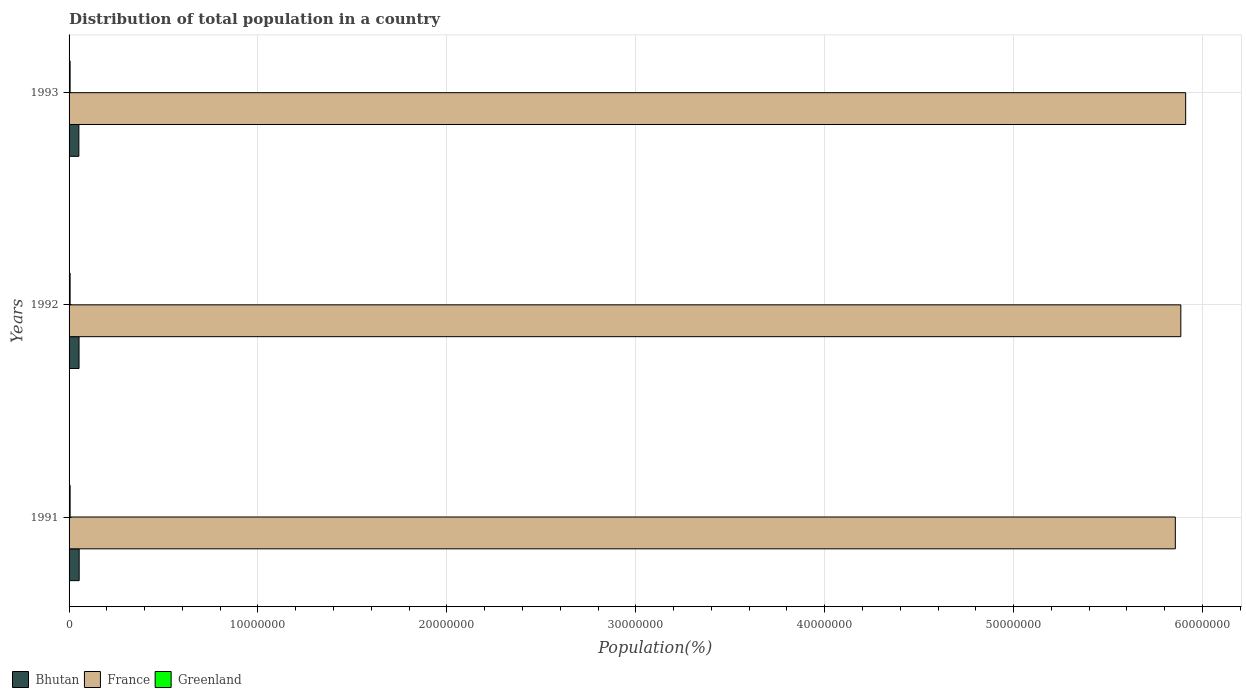How many groups of bars are there?
Keep it short and to the point. 3. Are the number of bars on each tick of the Y-axis equal?
Offer a terse response. Yes. In how many cases, is the number of bars for a given year not equal to the number of legend labels?
Keep it short and to the point. 0. What is the population of in Greenland in 1993?
Make the answer very short. 5.52e+04. Across all years, what is the maximum population of in France?
Ensure brevity in your answer.  5.91e+07. Across all years, what is the minimum population of in Bhutan?
Keep it short and to the point. 5.19e+05. In which year was the population of in Greenland maximum?
Your answer should be very brief. 1991. In which year was the population of in Greenland minimum?
Give a very brief answer. 1993. What is the total population of in Greenland in the graph?
Your response must be concise. 1.66e+05. What is the difference between the population of in France in 1991 and that in 1993?
Make the answer very short. -5.47e+05. What is the difference between the population of in Greenland in 1993 and the population of in Bhutan in 1991?
Give a very brief answer. -4.79e+05. What is the average population of in France per year?
Keep it short and to the point. 5.88e+07. In the year 1992, what is the difference between the population of in Greenland and population of in Bhutan?
Your response must be concise. -4.73e+05. What is the ratio of the population of in France in 1991 to that in 1992?
Your answer should be very brief. 1. Is the difference between the population of in Greenland in 1992 and 1993 greater than the difference between the population of in Bhutan in 1992 and 1993?
Provide a short and direct response. No. What is the difference between the highest and the second highest population of in Bhutan?
Your response must be concise. 6593. What is the difference between the highest and the lowest population of in Greenland?
Make the answer very short. 300. What does the 1st bar from the top in 1993 represents?
Offer a terse response. Greenland. What does the 2nd bar from the bottom in 1993 represents?
Provide a short and direct response. France. Is it the case that in every year, the sum of the population of in Greenland and population of in France is greater than the population of in Bhutan?
Ensure brevity in your answer.  Yes. How many years are there in the graph?
Keep it short and to the point. 3. What is the difference between two consecutive major ticks on the X-axis?
Provide a succinct answer. 1.00e+07. Does the graph contain grids?
Ensure brevity in your answer.  Yes. Where does the legend appear in the graph?
Give a very brief answer. Bottom left. How many legend labels are there?
Provide a succinct answer. 3. How are the legend labels stacked?
Offer a very short reply. Horizontal. What is the title of the graph?
Make the answer very short. Distribution of total population in a country. What is the label or title of the X-axis?
Your response must be concise. Population(%). What is the Population(%) of Bhutan in 1991?
Make the answer very short. 5.35e+05. What is the Population(%) in France in 1991?
Provide a succinct answer. 5.86e+07. What is the Population(%) in Greenland in 1991?
Provide a short and direct response. 5.55e+04. What is the Population(%) of Bhutan in 1992?
Provide a succinct answer. 5.28e+05. What is the Population(%) of France in 1992?
Make the answer very short. 5.89e+07. What is the Population(%) of Greenland in 1992?
Keep it short and to the point. 5.53e+04. What is the Population(%) in Bhutan in 1993?
Ensure brevity in your answer.  5.19e+05. What is the Population(%) of France in 1993?
Provide a succinct answer. 5.91e+07. What is the Population(%) of Greenland in 1993?
Ensure brevity in your answer.  5.52e+04. Across all years, what is the maximum Population(%) of Bhutan?
Your answer should be compact. 5.35e+05. Across all years, what is the maximum Population(%) of France?
Give a very brief answer. 5.91e+07. Across all years, what is the maximum Population(%) in Greenland?
Make the answer very short. 5.55e+04. Across all years, what is the minimum Population(%) in Bhutan?
Ensure brevity in your answer.  5.19e+05. Across all years, what is the minimum Population(%) of France?
Offer a terse response. 5.86e+07. Across all years, what is the minimum Population(%) of Greenland?
Provide a short and direct response. 5.52e+04. What is the total Population(%) in Bhutan in the graph?
Provide a succinct answer. 1.58e+06. What is the total Population(%) in France in the graph?
Keep it short and to the point. 1.77e+08. What is the total Population(%) of Greenland in the graph?
Provide a short and direct response. 1.66e+05. What is the difference between the Population(%) of Bhutan in 1991 and that in 1992?
Offer a very short reply. 6593. What is the difference between the Population(%) in France in 1991 and that in 1992?
Provide a short and direct response. -2.92e+05. What is the difference between the Population(%) of Bhutan in 1991 and that in 1993?
Give a very brief answer. 1.58e+04. What is the difference between the Population(%) in France in 1991 and that in 1993?
Offer a terse response. -5.47e+05. What is the difference between the Population(%) in Greenland in 1991 and that in 1993?
Make the answer very short. 300. What is the difference between the Population(%) of Bhutan in 1992 and that in 1993?
Keep it short and to the point. 9238. What is the difference between the Population(%) in France in 1992 and that in 1993?
Give a very brief answer. -2.56e+05. What is the difference between the Population(%) of Greenland in 1992 and that in 1993?
Ensure brevity in your answer.  100. What is the difference between the Population(%) in Bhutan in 1991 and the Population(%) in France in 1992?
Your answer should be compact. -5.83e+07. What is the difference between the Population(%) of Bhutan in 1991 and the Population(%) of Greenland in 1992?
Ensure brevity in your answer.  4.79e+05. What is the difference between the Population(%) in France in 1991 and the Population(%) in Greenland in 1992?
Make the answer very short. 5.85e+07. What is the difference between the Population(%) in Bhutan in 1991 and the Population(%) in France in 1993?
Offer a terse response. -5.86e+07. What is the difference between the Population(%) of Bhutan in 1991 and the Population(%) of Greenland in 1993?
Give a very brief answer. 4.79e+05. What is the difference between the Population(%) of France in 1991 and the Population(%) of Greenland in 1993?
Offer a terse response. 5.85e+07. What is the difference between the Population(%) of Bhutan in 1992 and the Population(%) of France in 1993?
Make the answer very short. -5.86e+07. What is the difference between the Population(%) in Bhutan in 1992 and the Population(%) in Greenland in 1993?
Offer a terse response. 4.73e+05. What is the difference between the Population(%) of France in 1992 and the Population(%) of Greenland in 1993?
Provide a short and direct response. 5.88e+07. What is the average Population(%) of Bhutan per year?
Ensure brevity in your answer.  5.27e+05. What is the average Population(%) in France per year?
Your answer should be very brief. 5.88e+07. What is the average Population(%) of Greenland per year?
Your answer should be compact. 5.53e+04. In the year 1991, what is the difference between the Population(%) of Bhutan and Population(%) of France?
Your answer should be compact. -5.80e+07. In the year 1991, what is the difference between the Population(%) in Bhutan and Population(%) in Greenland?
Offer a terse response. 4.79e+05. In the year 1991, what is the difference between the Population(%) in France and Population(%) in Greenland?
Your answer should be very brief. 5.85e+07. In the year 1992, what is the difference between the Population(%) of Bhutan and Population(%) of France?
Offer a very short reply. -5.83e+07. In the year 1992, what is the difference between the Population(%) in Bhutan and Population(%) in Greenland?
Ensure brevity in your answer.  4.73e+05. In the year 1992, what is the difference between the Population(%) in France and Population(%) in Greenland?
Give a very brief answer. 5.88e+07. In the year 1993, what is the difference between the Population(%) in Bhutan and Population(%) in France?
Offer a very short reply. -5.86e+07. In the year 1993, what is the difference between the Population(%) of Bhutan and Population(%) of Greenland?
Provide a short and direct response. 4.64e+05. In the year 1993, what is the difference between the Population(%) in France and Population(%) in Greenland?
Offer a very short reply. 5.91e+07. What is the ratio of the Population(%) in Bhutan in 1991 to that in 1992?
Provide a succinct answer. 1.01. What is the ratio of the Population(%) of Bhutan in 1991 to that in 1993?
Provide a succinct answer. 1.03. What is the ratio of the Population(%) in Greenland in 1991 to that in 1993?
Make the answer very short. 1.01. What is the ratio of the Population(%) of Bhutan in 1992 to that in 1993?
Offer a terse response. 1.02. What is the ratio of the Population(%) in France in 1992 to that in 1993?
Provide a succinct answer. 1. What is the difference between the highest and the second highest Population(%) in Bhutan?
Keep it short and to the point. 6593. What is the difference between the highest and the second highest Population(%) in France?
Provide a short and direct response. 2.56e+05. What is the difference between the highest and the second highest Population(%) of Greenland?
Keep it short and to the point. 200. What is the difference between the highest and the lowest Population(%) in Bhutan?
Offer a very short reply. 1.58e+04. What is the difference between the highest and the lowest Population(%) in France?
Your answer should be very brief. 5.47e+05. What is the difference between the highest and the lowest Population(%) in Greenland?
Your answer should be very brief. 300. 